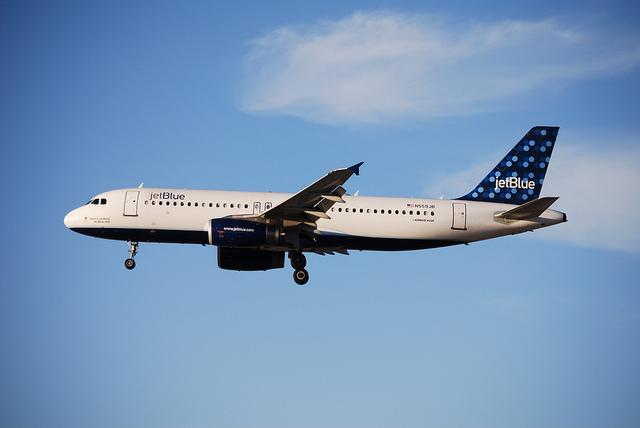Is the plane landing?
Be succinct. Yes. Is the plane going to land immediately?
Write a very short answer. No. What color is the sky?
Short answer required. Blue. To which airline does this plane belong?
Quick response, please. Jetblue. 